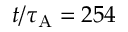<formula> <loc_0><loc_0><loc_500><loc_500>t / \tau _ { A } = 2 5 4</formula> 